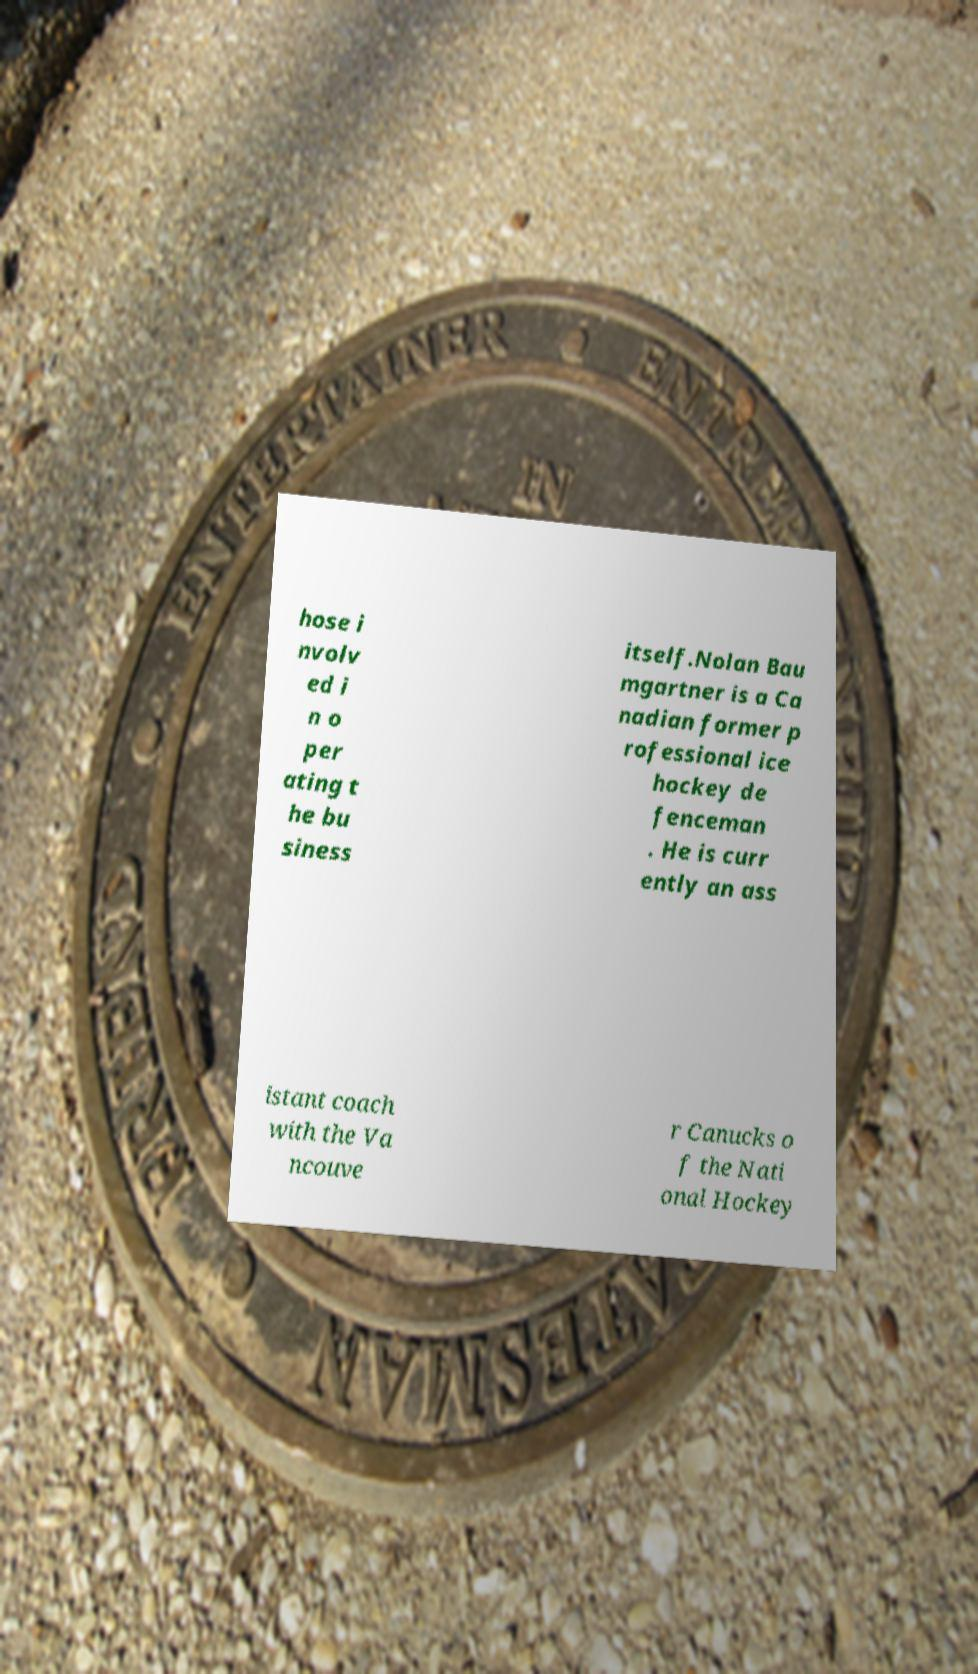Can you accurately transcribe the text from the provided image for me? hose i nvolv ed i n o per ating t he bu siness itself.Nolan Bau mgartner is a Ca nadian former p rofessional ice hockey de fenceman . He is curr ently an ass istant coach with the Va ncouve r Canucks o f the Nati onal Hockey 